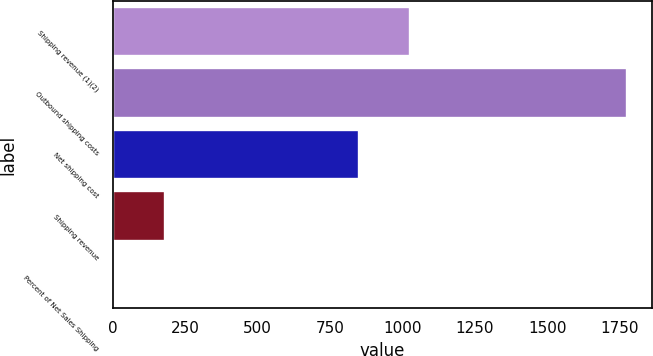<chart> <loc_0><loc_0><loc_500><loc_500><bar_chart><fcel>Shipping revenue (1)(2)<fcel>Outbound shipping costs<fcel>Net shipping cost<fcel>Shipping revenue<fcel>Percent of Net Sales Shipping<nl><fcel>1025.92<fcel>1773<fcel>849<fcel>180.72<fcel>3.8<nl></chart> 